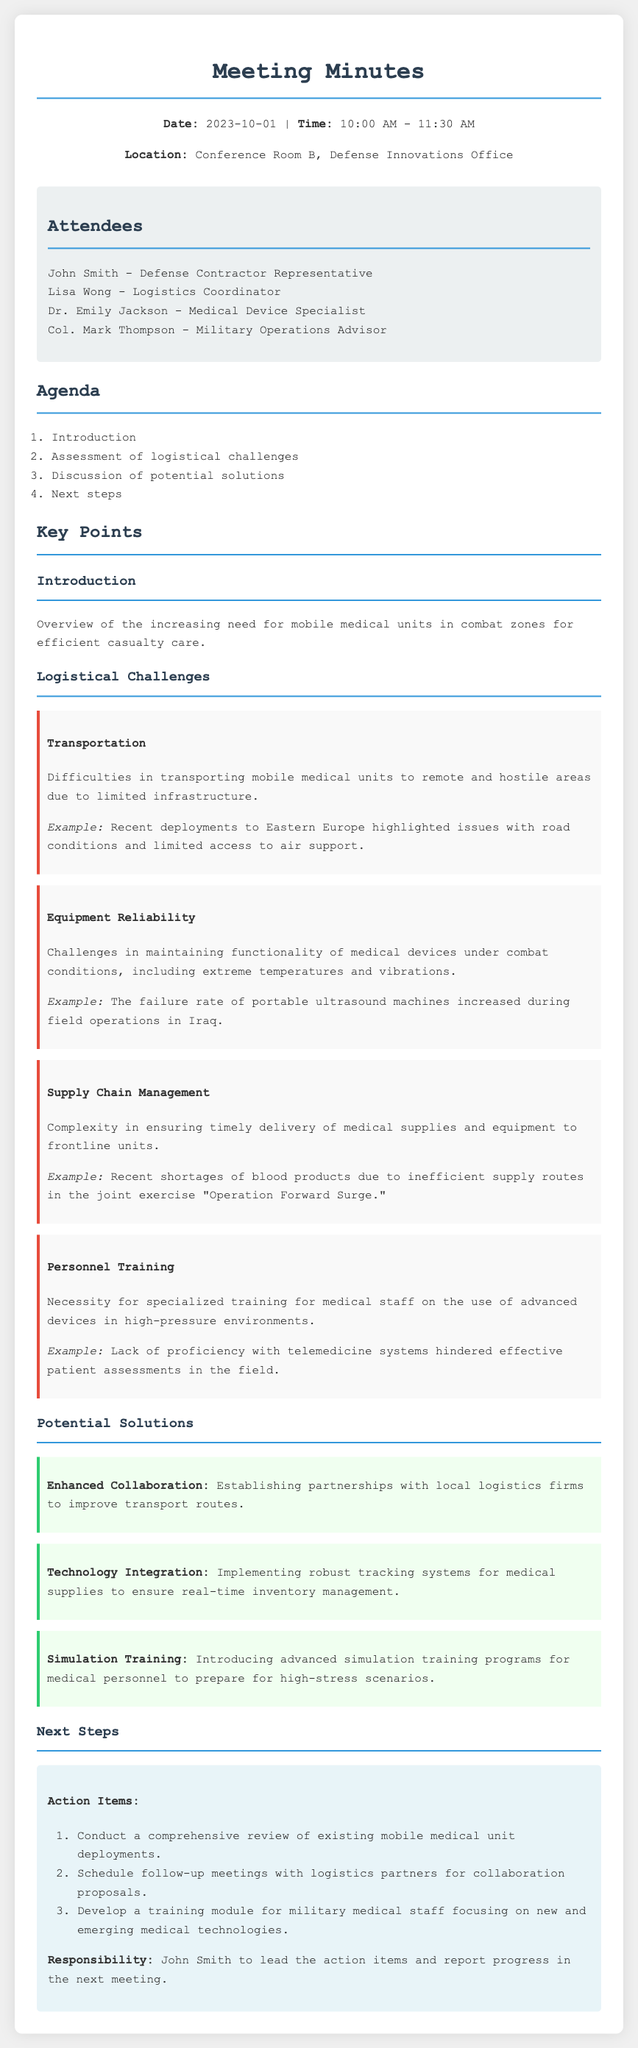What was the date of the meeting? The document specifies the meeting date as 2023-10-01.
Answer: 2023-10-01 Who is the Medical Device Specialist that attended the meeting? The document lists Dr. Emily Jackson as the Medical Device Specialist.
Answer: Dr. Emily Jackson What was one example of a transportation issue mentioned? The meeting minutes state that recent deployments to Eastern Europe highlighted issues with road conditions.
Answer: Road conditions What is one proposed solution for improving supply chain management? The minutes suggest implementing robust tracking systems for medical supplies for inventory management.
Answer: Robust tracking systems What is one of the action items for next steps? The meeting outlines conducting a comprehensive review of existing mobile medical unit deployments as an action item.
Answer: Conduct a comprehensive review What time did the meeting start? The document mentions the meeting started at 10:00 AM.
Answer: 10:00 AM What was one of the logistical challenges regarding personnel? The notes highlight the necessity for specialized training for medical staff on advanced devices.
Answer: Specialized training How many attendees were present at the meeting? The document lists four attendees in the 'Attendees' section.
Answer: Four 